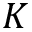Convert formula to latex. <formula><loc_0><loc_0><loc_500><loc_500>K</formula> 